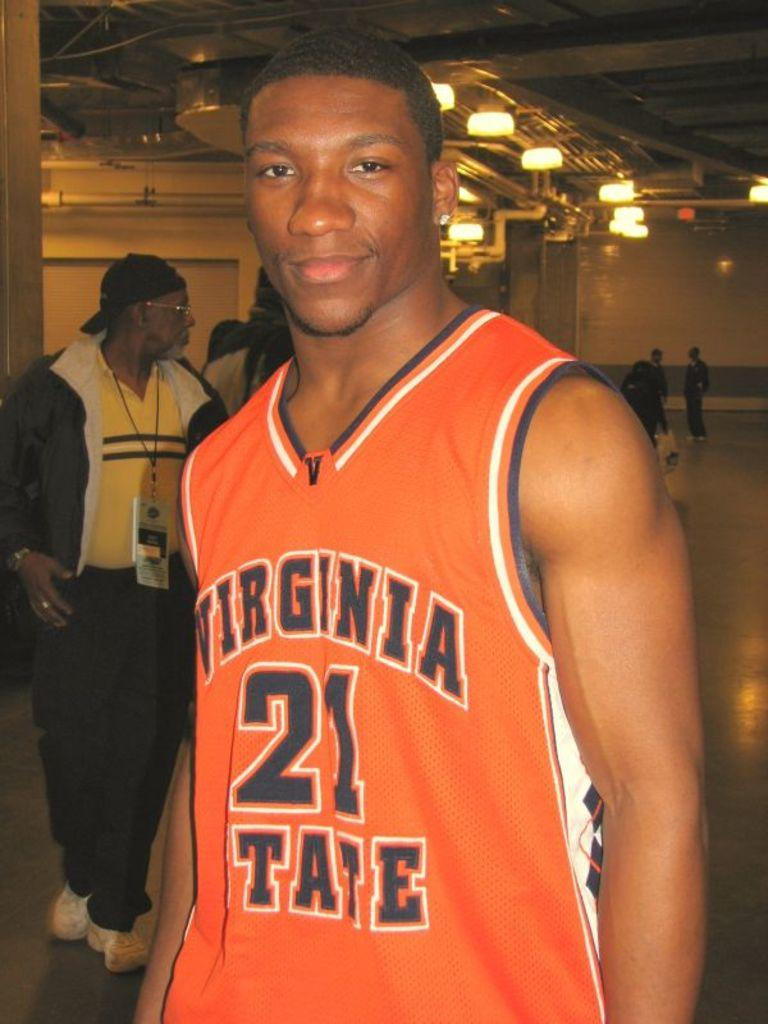Provide a one-sentence caption for the provided image. A basketball player for Virginia State wearing number 21 smiles for the camera. 